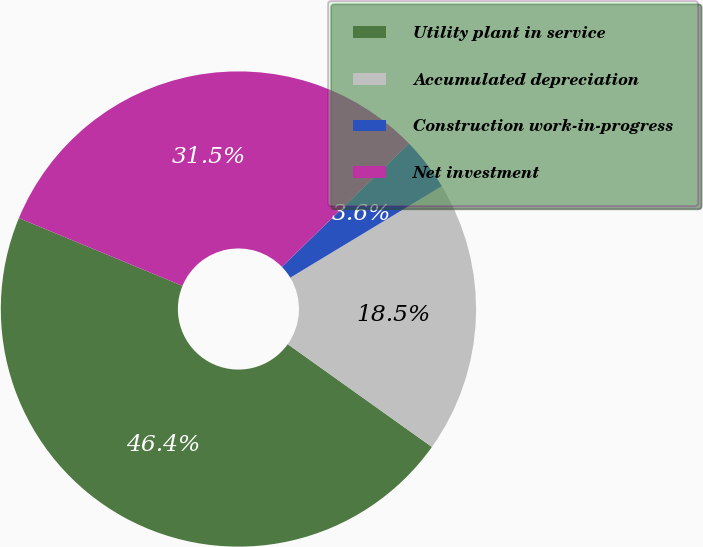Convert chart. <chart><loc_0><loc_0><loc_500><loc_500><pie_chart><fcel>Utility plant in service<fcel>Accumulated depreciation<fcel>Construction work-in-progress<fcel>Net investment<nl><fcel>46.39%<fcel>18.51%<fcel>3.61%<fcel>31.49%<nl></chart> 